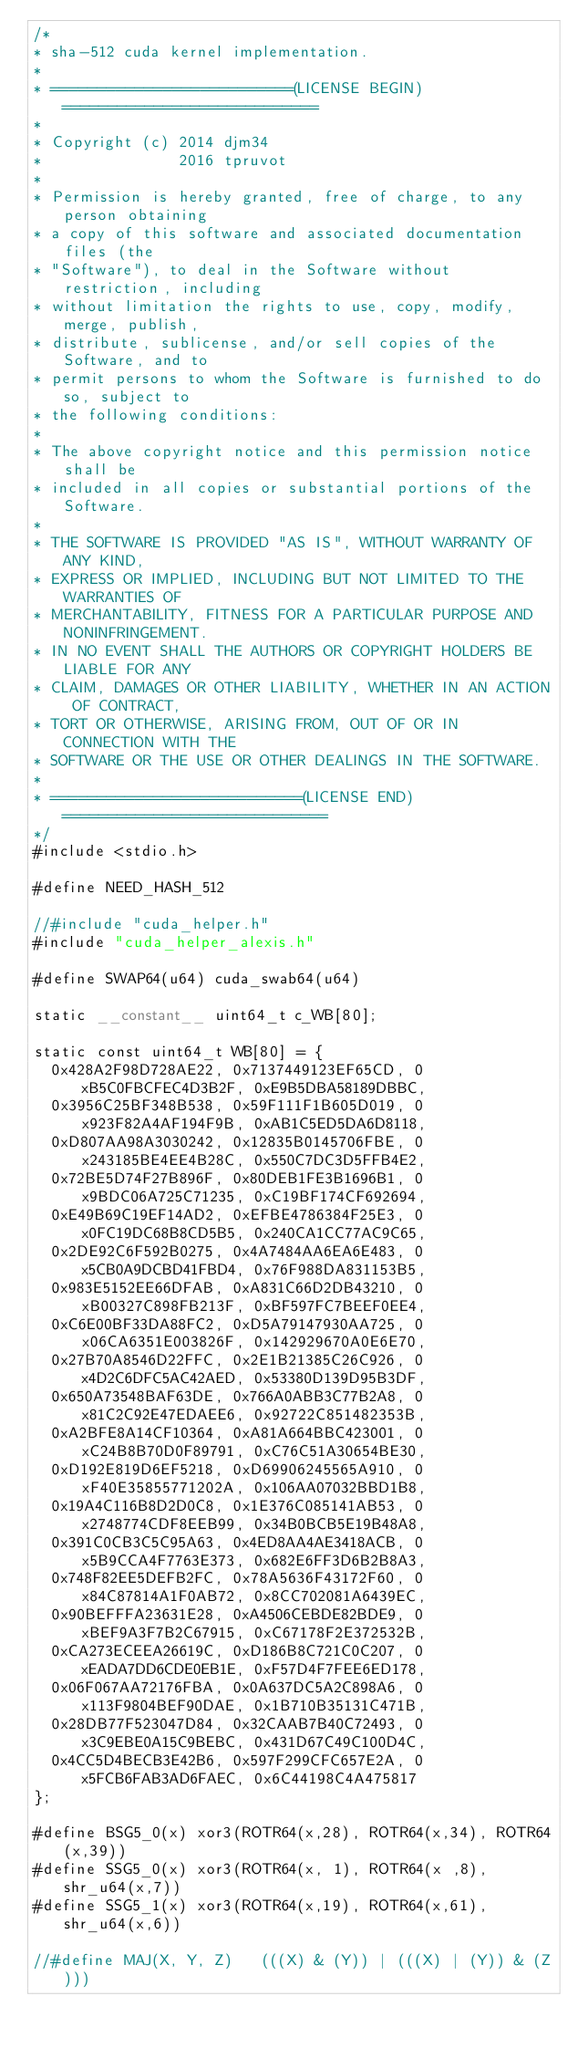<code> <loc_0><loc_0><loc_500><loc_500><_Cuda_>/*
* sha-512 cuda kernel implementation.
*
* ==========================(LICENSE BEGIN)============================
*
* Copyright (c) 2014 djm34
*               2016 tpruvot
*
* Permission is hereby granted, free of charge, to any person obtaining
* a copy of this software and associated documentation files (the
* "Software"), to deal in the Software without restriction, including
* without limitation the rights to use, copy, modify, merge, publish,
* distribute, sublicense, and/or sell copies of the Software, and to
* permit persons to whom the Software is furnished to do so, subject to
* the following conditions:
*
* The above copyright notice and this permission notice shall be
* included in all copies or substantial portions of the Software.
*
* THE SOFTWARE IS PROVIDED "AS IS", WITHOUT WARRANTY OF ANY KIND,
* EXPRESS OR IMPLIED, INCLUDING BUT NOT LIMITED TO THE WARRANTIES OF
* MERCHANTABILITY, FITNESS FOR A PARTICULAR PURPOSE AND NONINFRINGEMENT.
* IN NO EVENT SHALL THE AUTHORS OR COPYRIGHT HOLDERS BE LIABLE FOR ANY
* CLAIM, DAMAGES OR OTHER LIABILITY, WHETHER IN AN ACTION OF CONTRACT,
* TORT OR OTHERWISE, ARISING FROM, OUT OF OR IN CONNECTION WITH THE
* SOFTWARE OR THE USE OR OTHER DEALINGS IN THE SOFTWARE.
*
* ===========================(LICENSE END)=============================
*/
#include <stdio.h>

#define NEED_HASH_512

//#include "cuda_helper.h"
#include "cuda_helper_alexis.h"

#define SWAP64(u64) cuda_swab64(u64)

static __constant__ uint64_t c_WB[80];

static const uint64_t WB[80] = {
	0x428A2F98D728AE22, 0x7137449123EF65CD, 0xB5C0FBCFEC4D3B2F, 0xE9B5DBA58189DBBC,
	0x3956C25BF348B538, 0x59F111F1B605D019, 0x923F82A4AF194F9B, 0xAB1C5ED5DA6D8118,
	0xD807AA98A3030242, 0x12835B0145706FBE, 0x243185BE4EE4B28C, 0x550C7DC3D5FFB4E2,
	0x72BE5D74F27B896F, 0x80DEB1FE3B1696B1, 0x9BDC06A725C71235, 0xC19BF174CF692694,
	0xE49B69C19EF14AD2, 0xEFBE4786384F25E3, 0x0FC19DC68B8CD5B5, 0x240CA1CC77AC9C65,
	0x2DE92C6F592B0275, 0x4A7484AA6EA6E483, 0x5CB0A9DCBD41FBD4, 0x76F988DA831153B5,
	0x983E5152EE66DFAB, 0xA831C66D2DB43210, 0xB00327C898FB213F, 0xBF597FC7BEEF0EE4,
	0xC6E00BF33DA88FC2, 0xD5A79147930AA725, 0x06CA6351E003826F, 0x142929670A0E6E70,
	0x27B70A8546D22FFC, 0x2E1B21385C26C926, 0x4D2C6DFC5AC42AED, 0x53380D139D95B3DF,
	0x650A73548BAF63DE, 0x766A0ABB3C77B2A8, 0x81C2C92E47EDAEE6, 0x92722C851482353B,
	0xA2BFE8A14CF10364, 0xA81A664BBC423001, 0xC24B8B70D0F89791, 0xC76C51A30654BE30,
	0xD192E819D6EF5218, 0xD69906245565A910, 0xF40E35855771202A, 0x106AA07032BBD1B8,
	0x19A4C116B8D2D0C8, 0x1E376C085141AB53, 0x2748774CDF8EEB99, 0x34B0BCB5E19B48A8,
	0x391C0CB3C5C95A63, 0x4ED8AA4AE3418ACB, 0x5B9CCA4F7763E373, 0x682E6FF3D6B2B8A3,
	0x748F82EE5DEFB2FC, 0x78A5636F43172F60, 0x84C87814A1F0AB72, 0x8CC702081A6439EC,
	0x90BEFFFA23631E28, 0xA4506CEBDE82BDE9, 0xBEF9A3F7B2C67915, 0xC67178F2E372532B,
	0xCA273ECEEA26619C, 0xD186B8C721C0C207, 0xEADA7DD6CDE0EB1E, 0xF57D4F7FEE6ED178,
	0x06F067AA72176FBA, 0x0A637DC5A2C898A6, 0x113F9804BEF90DAE, 0x1B710B35131C471B,
	0x28DB77F523047D84, 0x32CAAB7B40C72493, 0x3C9EBE0A15C9BEBC, 0x431D67C49C100D4C,
	0x4CC5D4BECB3E42B6, 0x597F299CFC657E2A, 0x5FCB6FAB3AD6FAEC, 0x6C44198C4A475817
};

#define BSG5_0(x) xor3(ROTR64(x,28), ROTR64(x,34), ROTR64(x,39))
#define SSG5_0(x) xor3(ROTR64(x, 1), ROTR64(x ,8), shr_u64(x,7))
#define SSG5_1(x) xor3(ROTR64(x,19), ROTR64(x,61), shr_u64(x,6))

//#define MAJ(X, Y, Z)   (((X) & (Y)) | (((X) | (Y)) & (Z)))</code> 